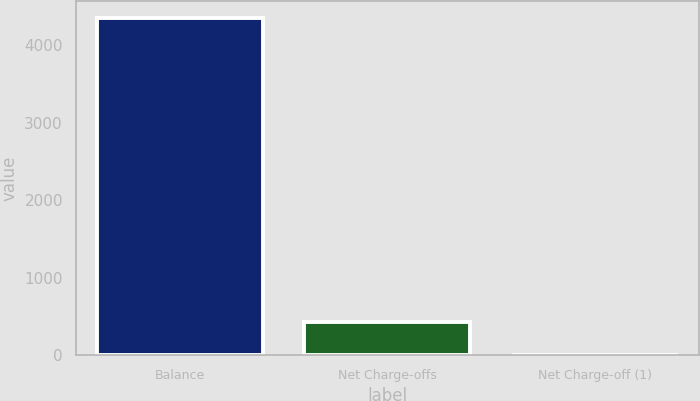<chart> <loc_0><loc_0><loc_500><loc_500><bar_chart><fcel>Balance<fcel>Net Charge-offs<fcel>Net Charge-off (1)<nl><fcel>4350<fcel>436.5<fcel>1.67<nl></chart> 